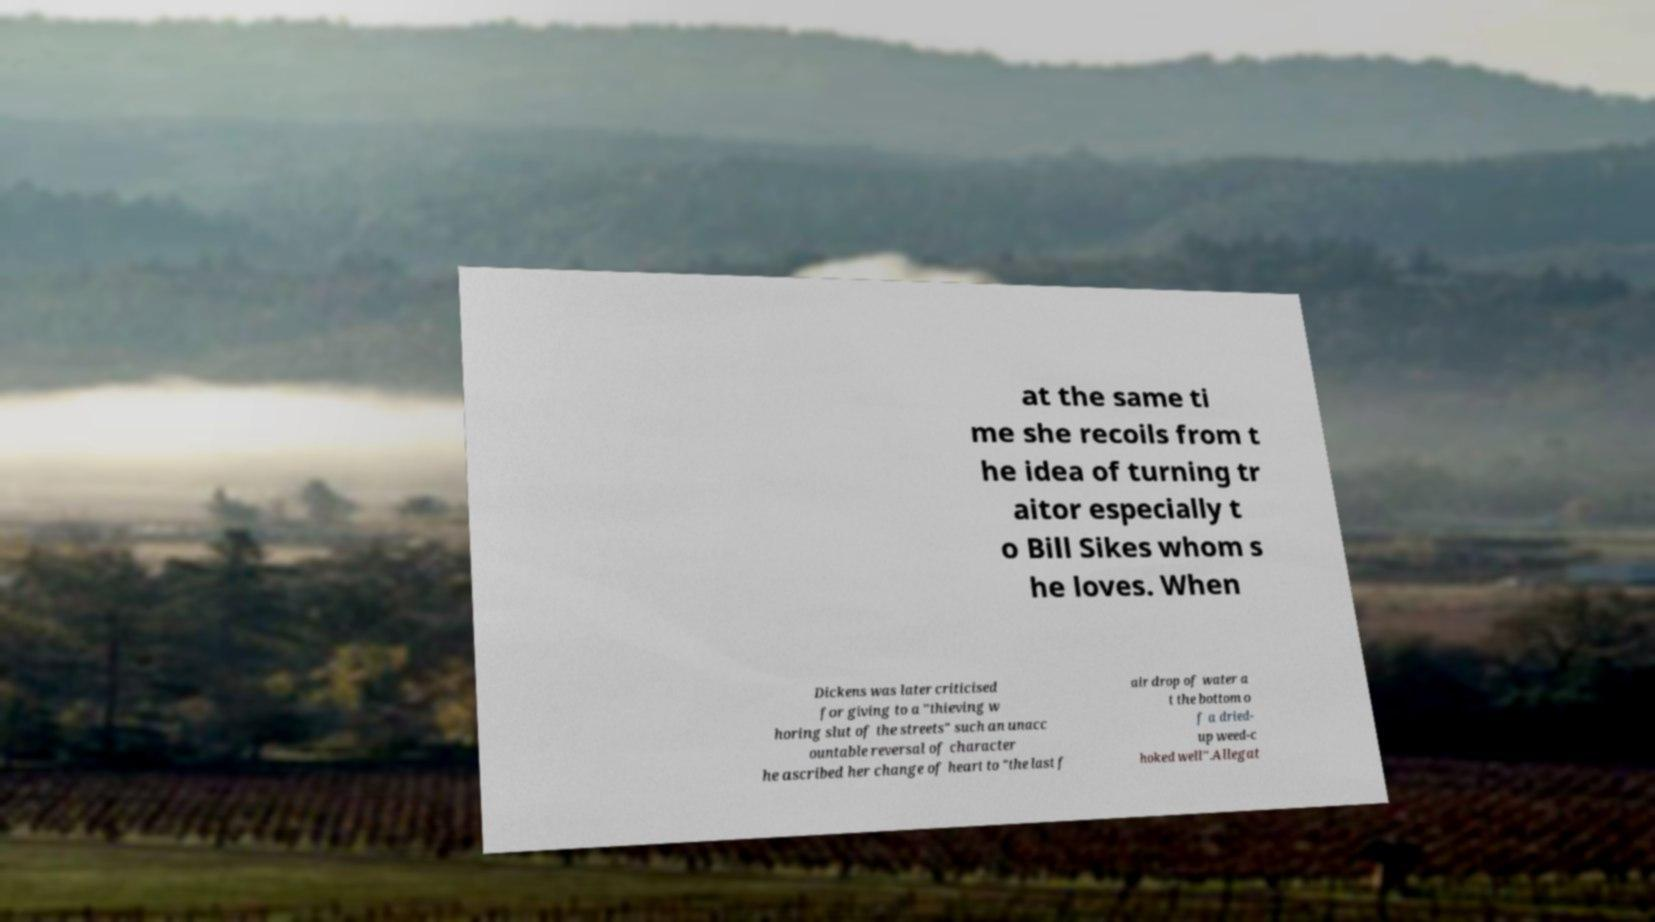Please read and relay the text visible in this image. What does it say? at the same ti me she recoils from t he idea of turning tr aitor especially t o Bill Sikes whom s he loves. When Dickens was later criticised for giving to a "thieving w horing slut of the streets" such an unacc ountable reversal of character he ascribed her change of heart to "the last f air drop of water a t the bottom o f a dried- up weed-c hoked well".Allegat 